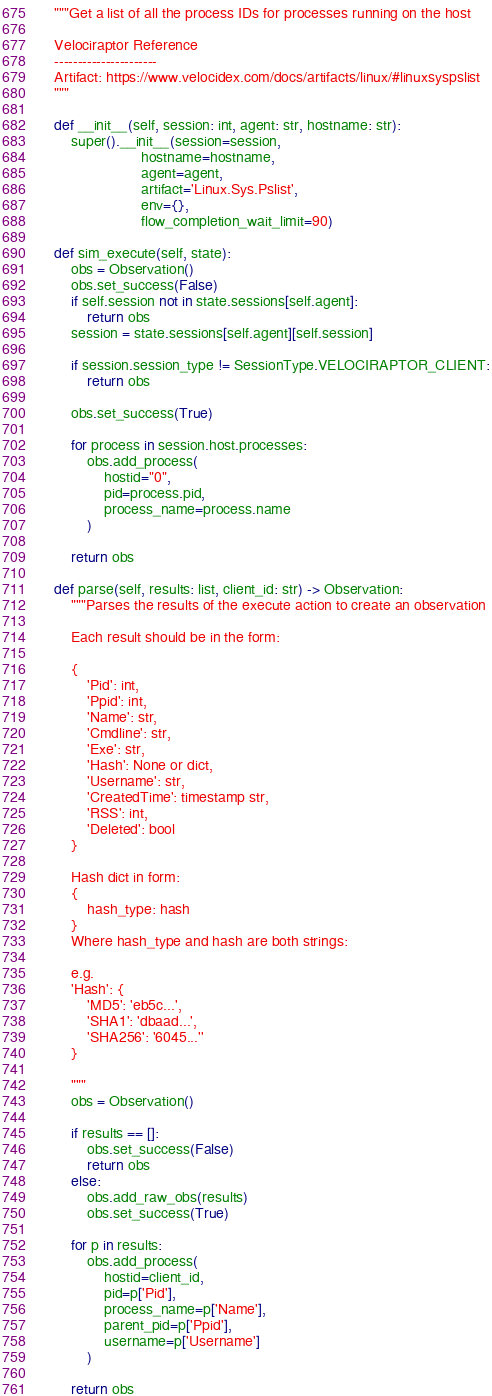Convert code to text. <code><loc_0><loc_0><loc_500><loc_500><_Python_>    """Get a list of all the process IDs for processes running on the host

    Velociraptor Reference
    ----------------------
    Artifact: https://www.velocidex.com/docs/artifacts/linux/#linuxsyspslist
    """

    def __init__(self, session: int, agent: str, hostname: str):
        super().__init__(session=session,
                         hostname=hostname,
                         agent=agent,
                         artifact='Linux.Sys.Pslist',
                         env={},
                         flow_completion_wait_limit=90)

    def sim_execute(self, state):
        obs = Observation()
        obs.set_success(False)
        if self.session not in state.sessions[self.agent]:
            return obs
        session = state.sessions[self.agent][self.session]

        if session.session_type != SessionType.VELOCIRAPTOR_CLIENT:
            return obs

        obs.set_success(True)

        for process in session.host.processes:
            obs.add_process(
                hostid="0",
                pid=process.pid,
                process_name=process.name
            )

        return obs

    def parse(self, results: list, client_id: str) -> Observation:
        """Parses the results of the execute action to create an observation

        Each result should be in the form:

        {
            'Pid': int,
            'Ppid': int,
            'Name': str,
            'Cmdline': str,
            'Exe': str,
            'Hash': None or dict,
            'Username': str,
            'CreatedTime': timestamp str,
            'RSS': int,
            'Deleted': bool
        }

        Hash dict in form:
        {
            hash_type: hash
        }
        Where hash_type and hash are both strings:

        e.g.
        'Hash': {
            'MD5': 'eb5c...',
            'SHA1': 'dbaad...',
            'SHA256': '6045...''
        }

        """
        obs = Observation()

        if results == []:
            obs.set_success(False)
            return obs
        else:
            obs.add_raw_obs(results)
            obs.set_success(True)

        for p in results:
            obs.add_process(
                hostid=client_id,
                pid=p['Pid'],
                process_name=p['Name'],
                parent_pid=p['Ppid'],
                username=p['Username']
            )

        return obs
</code> 